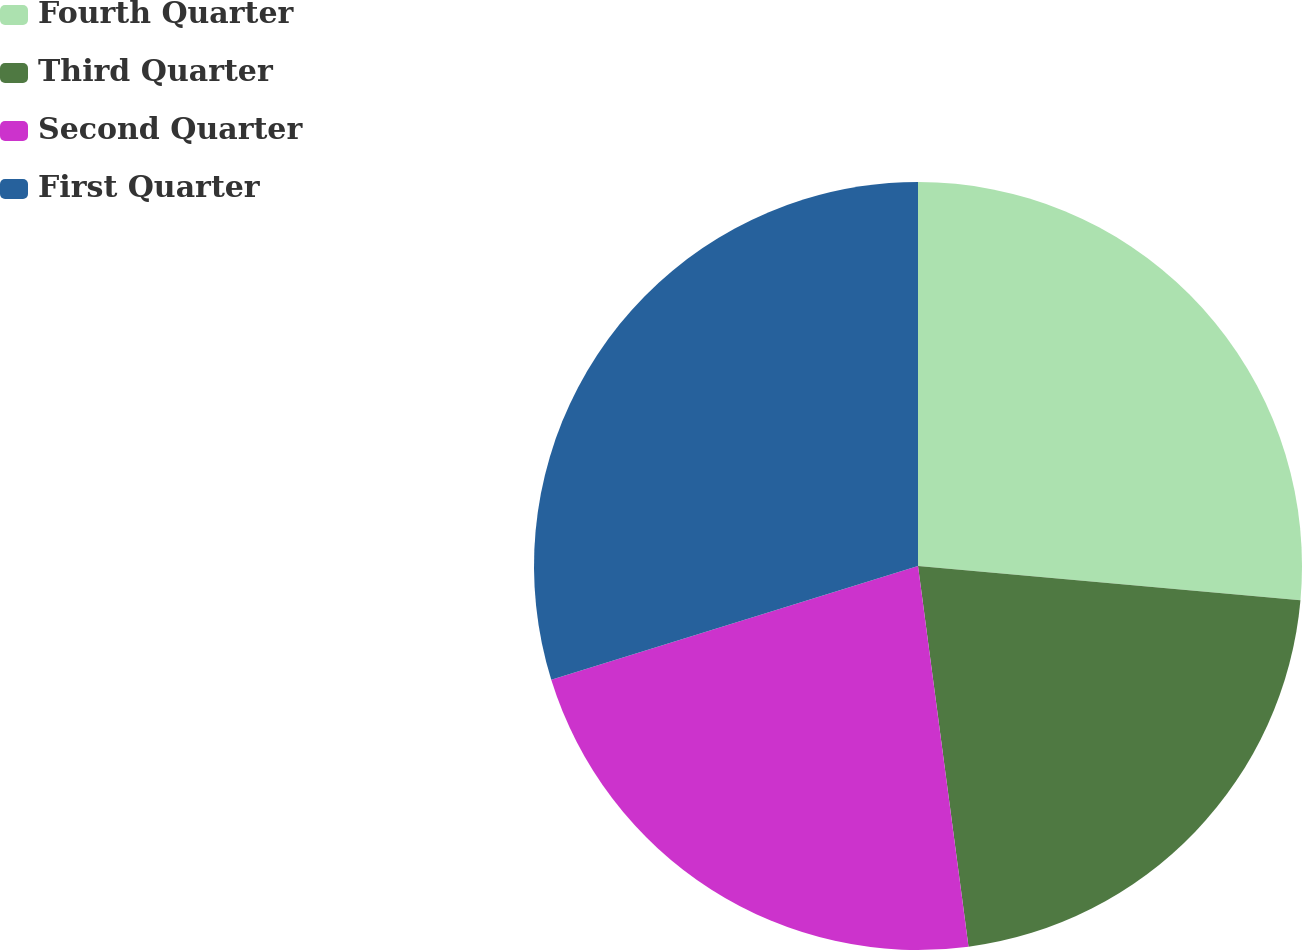Convert chart. <chart><loc_0><loc_0><loc_500><loc_500><pie_chart><fcel>Fourth Quarter<fcel>Third Quarter<fcel>Second Quarter<fcel>First Quarter<nl><fcel>26.42%<fcel>21.48%<fcel>22.31%<fcel>29.79%<nl></chart> 